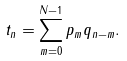<formula> <loc_0><loc_0><loc_500><loc_500>t _ { n } = \sum _ { m = 0 } ^ { N - 1 } p _ { m } q _ { n - m } .</formula> 